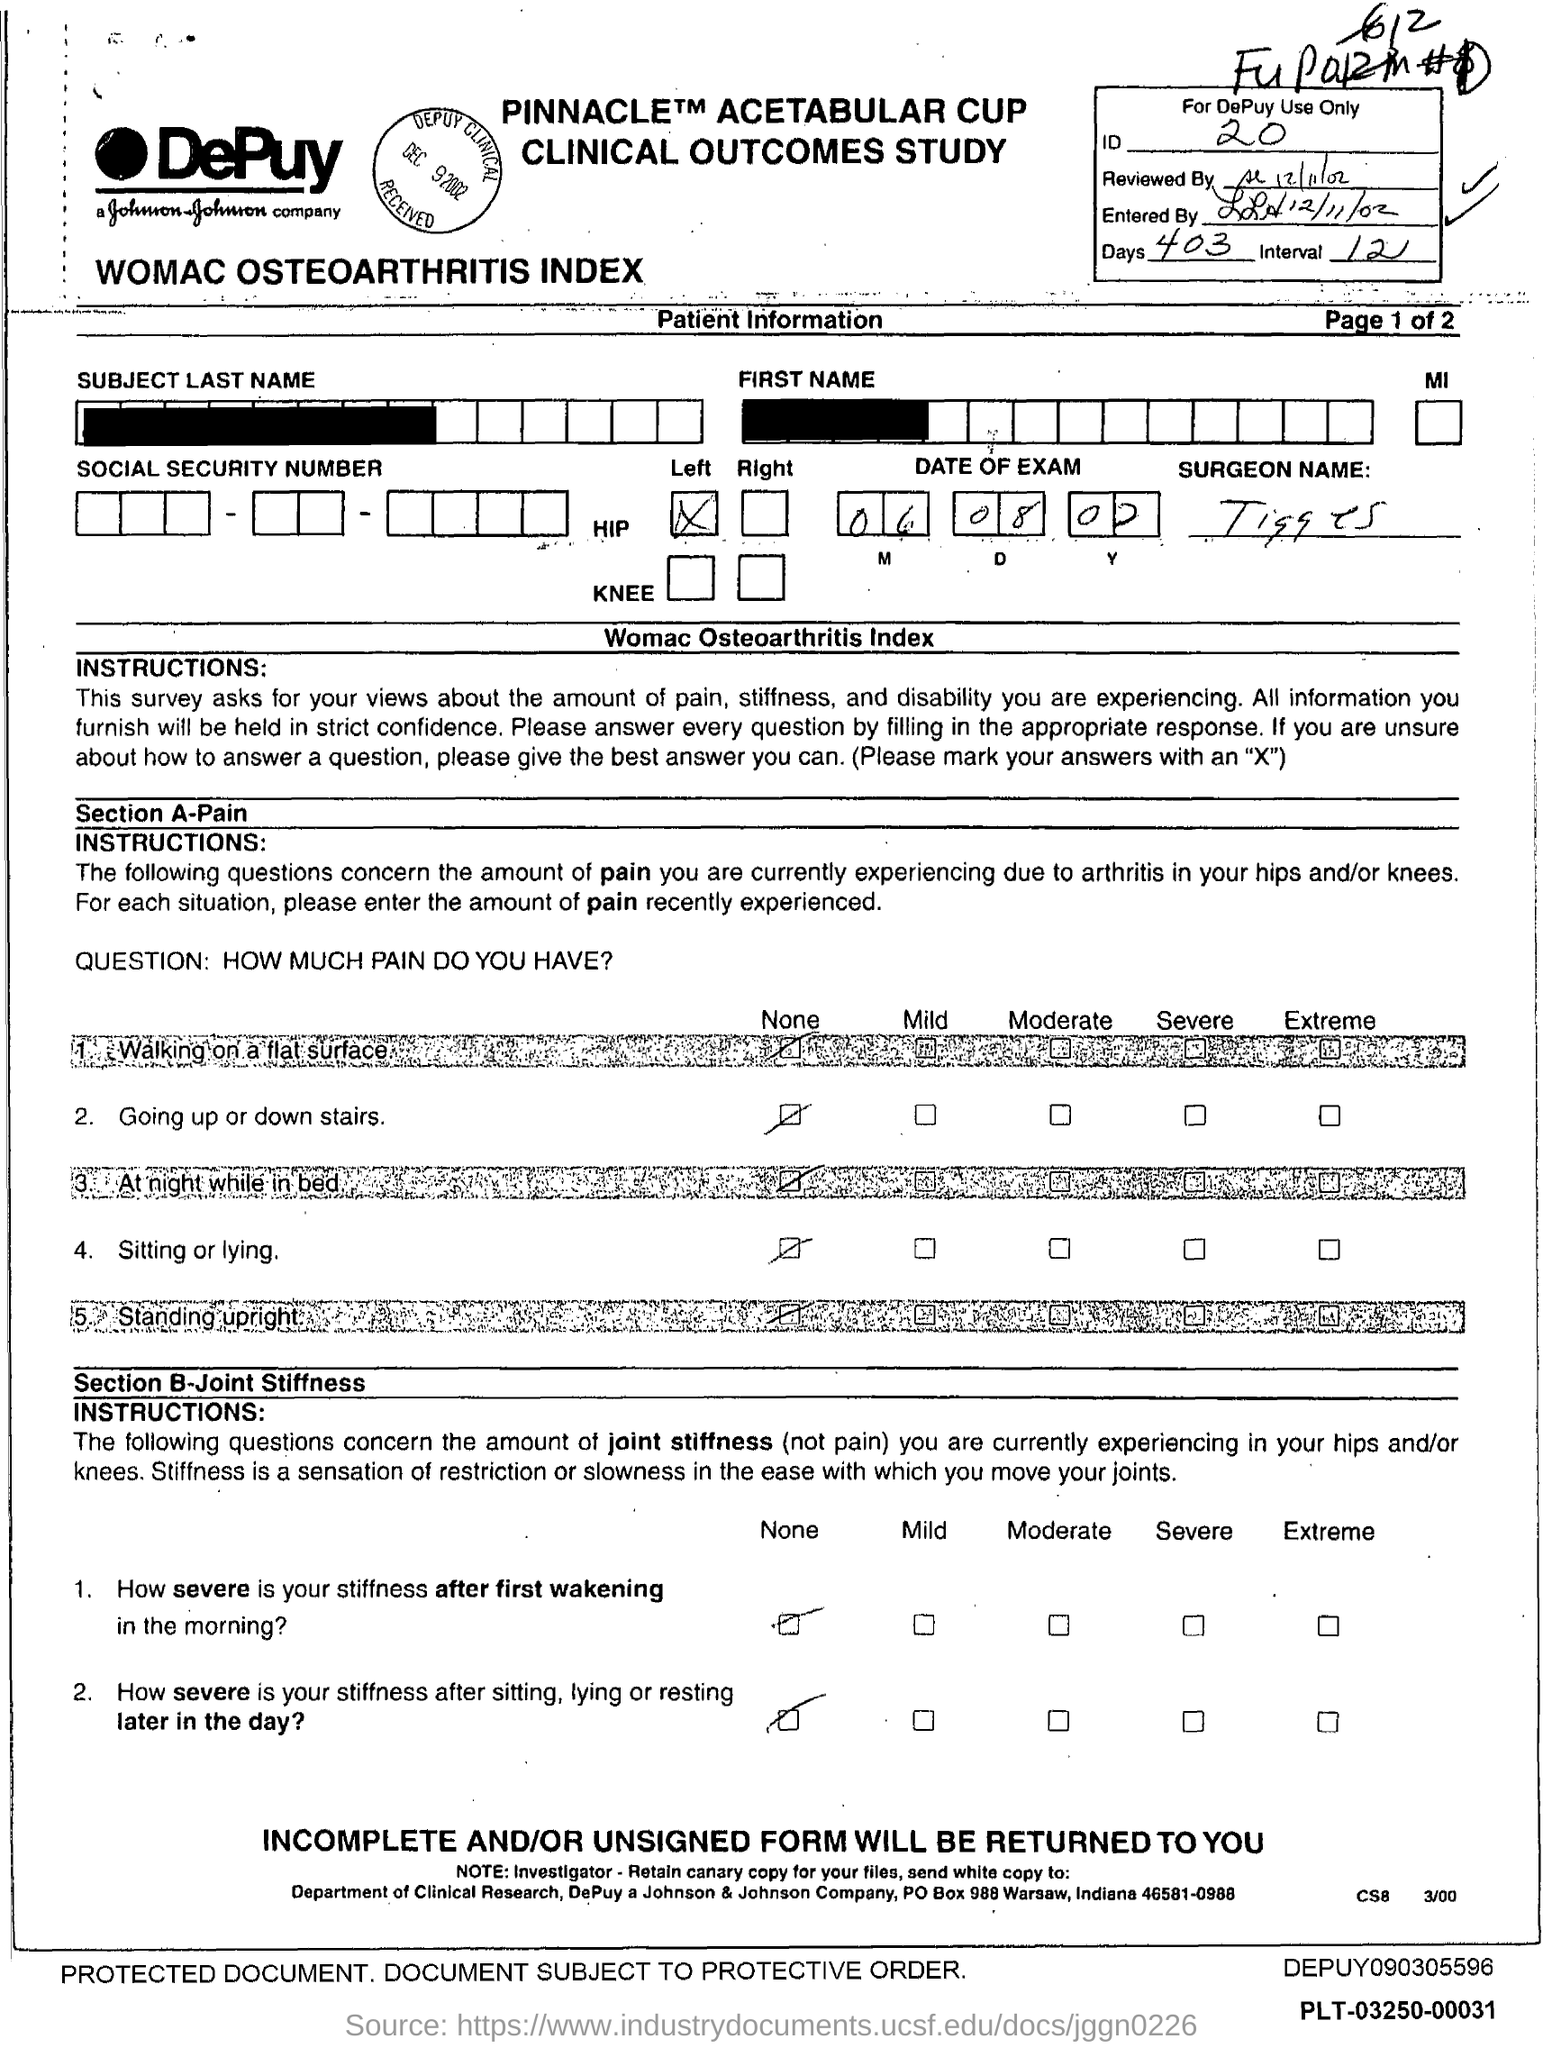Highlight a few significant elements in this photo. The number of days is 403. What is the ID Number? It is 20... The number of intervals in the range 12.. is 12. 